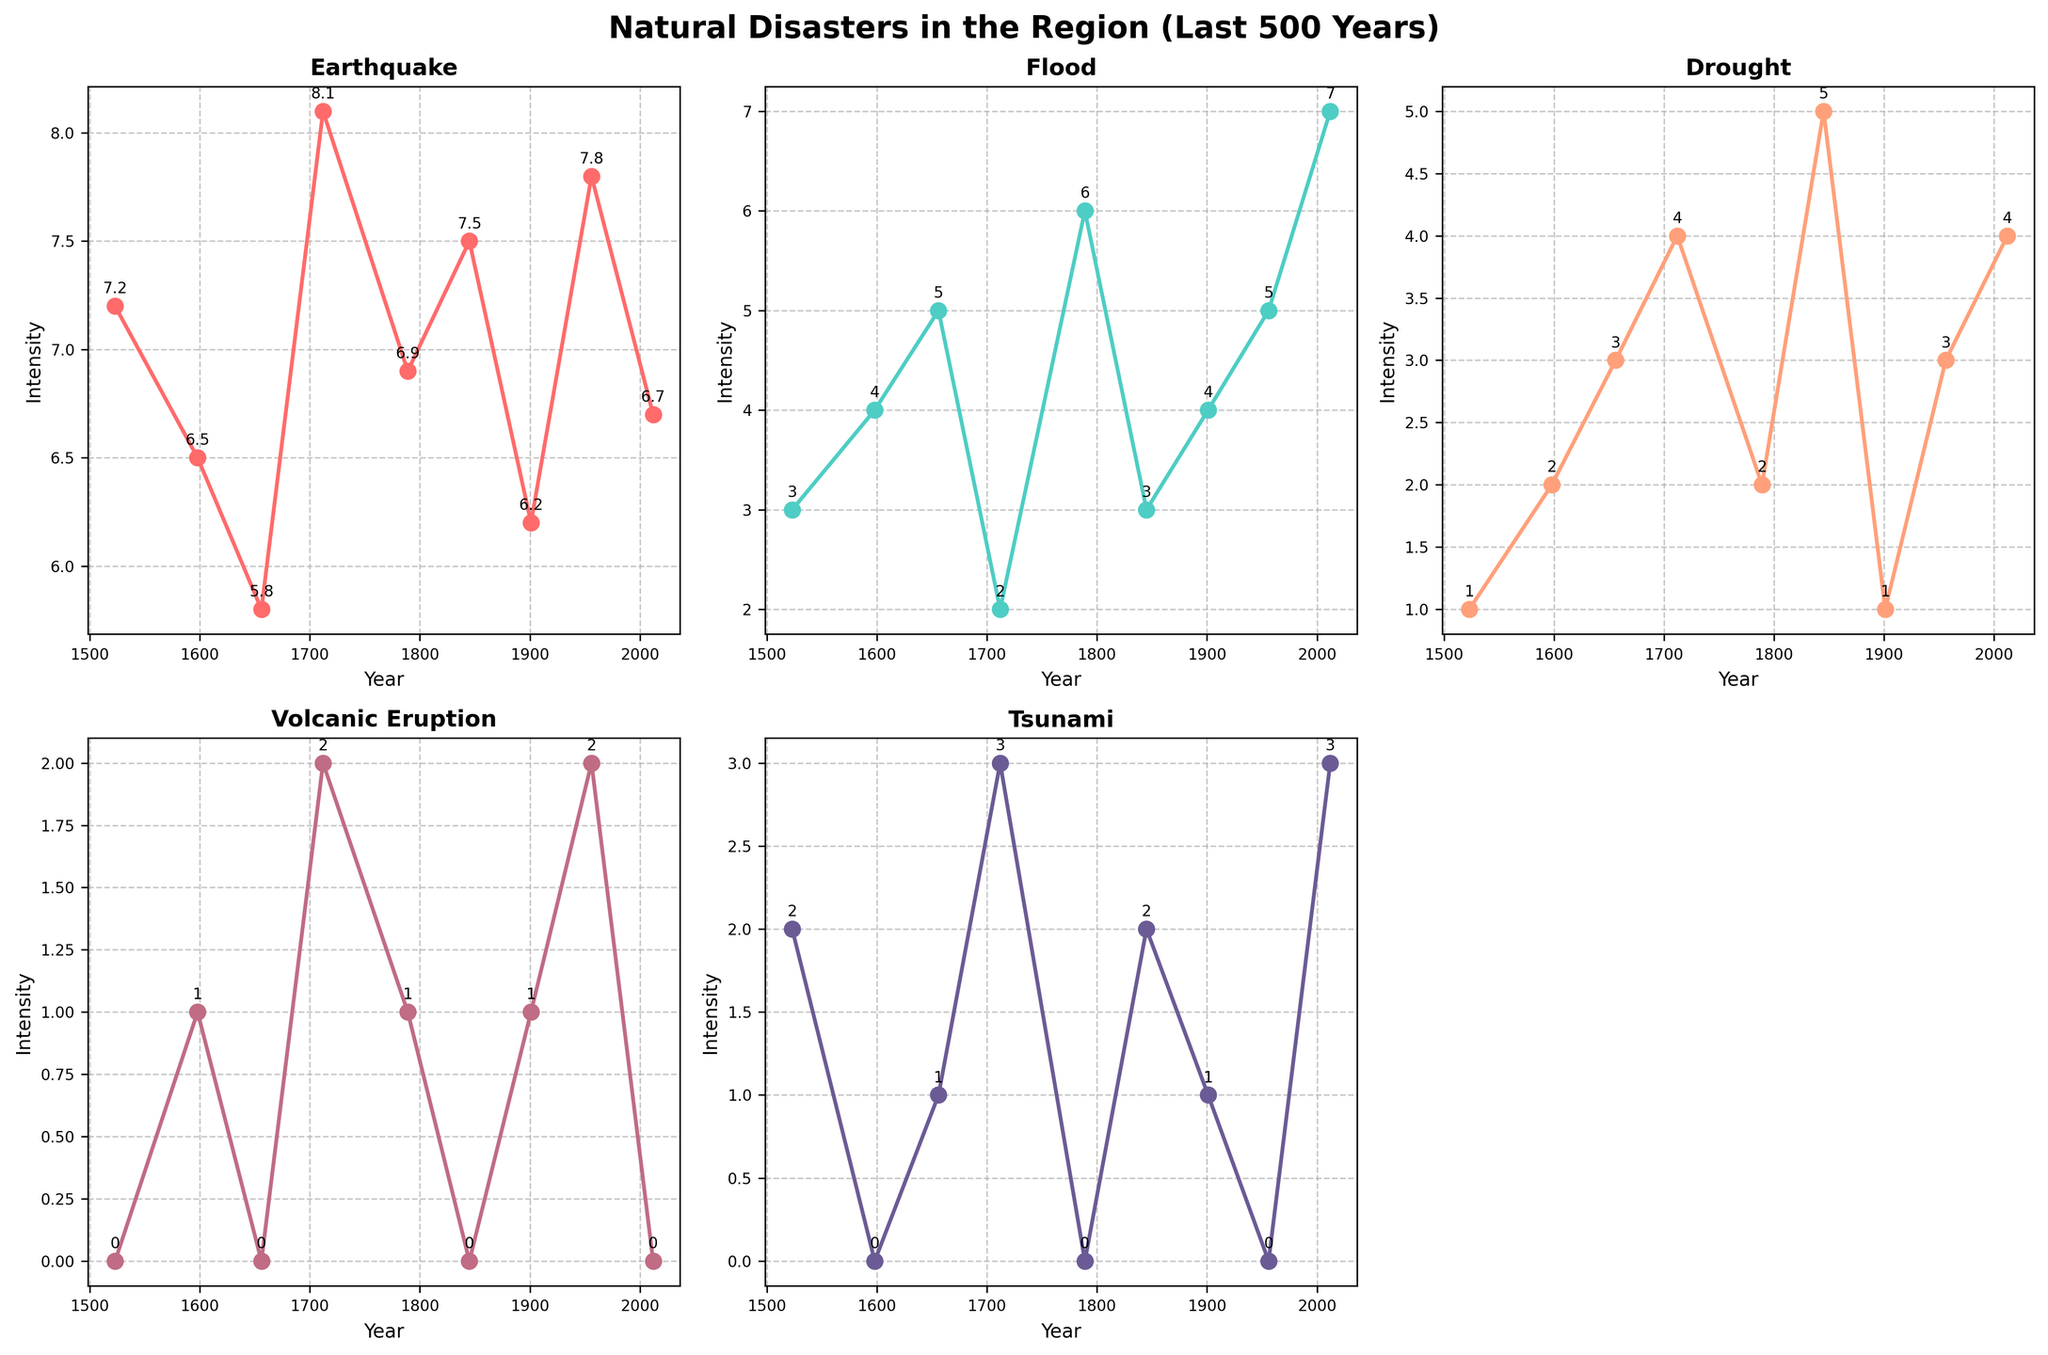What is the title of the figure? The title is located at the top of the figure, usually in a larger font size and bold. It provides an overview of what the figure is about.
Answer: Natural Disasters in the Region (Last 500 Years) Which disaster type has the highest intensity in 1712? By looking at the subplot titled "1712" and observing the y-axis for the highest point on the graph, the intensity values can be identified.
Answer: Earthquake How does the frequency of floods change over the 500 years? By examining the subplot for floods, one can follow the plotted line to see how the values on the y-axis change over time. This will show trends in frequency.
Answer: It generally increases Compare the intensity of droughts in 1656 and 2012. Which year had higher intensity? Look at the subplot for droughts and find the points corresponding to the years 1656 and 2012. Compare their positions on the y-axis.
Answer: 2012 What years had volcanic eruptions? In the volcanic eruption subplot, volcanic eruptions are indicated by non-zero points on the x-axis (years). Identify the corresponding years.
Answer: 1598, 1712, 1956 Among the subplots, which natural disaster type didn't occur at all in some periods? Inspect each subplot for periods where the y-axis value stays at zero to determine which disaster types had no events.
Answer: Volcanic Eruption What is the average intensity of tsunamis over the 500 years? In the tsunami subplot, sum up all the y-axis values and divide by the number of recorded years to find the average intensity.
Answer: 1.0 During which century did earthquakes show the highest intensity, and what was that intensity? Review the earthquake subplot to identify the highest peak and check the corresponding year to determine the century and intensity.
Answer: 18th century, 8.1 Which natural disaster showed a peak in intensity in 2012? Observe each subplot for the year 2012 and identify which subplot has the highest y-axis value for that year.
Answer: Tsunami How many total types of natural disasters are recorded in the figure? Count the number of different subplots as each corresponds to a different type of natural disaster.
Answer: 5 